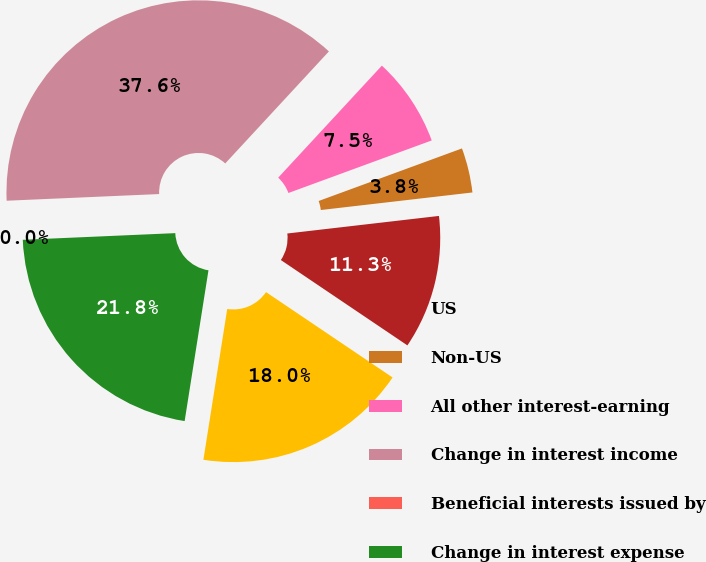Convert chart to OTSL. <chart><loc_0><loc_0><loc_500><loc_500><pie_chart><fcel>US<fcel>Non-US<fcel>All other interest-earning<fcel>Change in interest income<fcel>Beneficial interests issued by<fcel>Change in interest expense<fcel>Change in net interest income<nl><fcel>11.28%<fcel>3.76%<fcel>7.52%<fcel>37.58%<fcel>0.0%<fcel>21.81%<fcel>18.05%<nl></chart> 